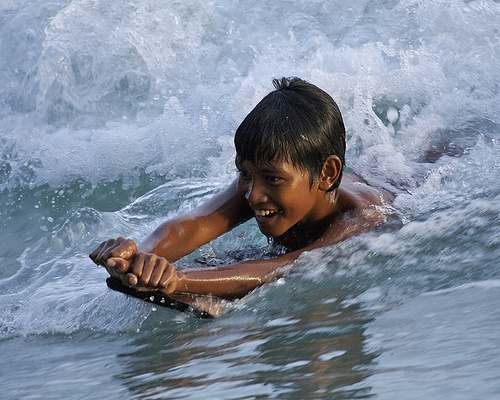Describe the objects in this image and their specific colors. I can see people in darkgray, black, gray, and maroon tones and surfboard in darkgray, black, and gray tones in this image. 